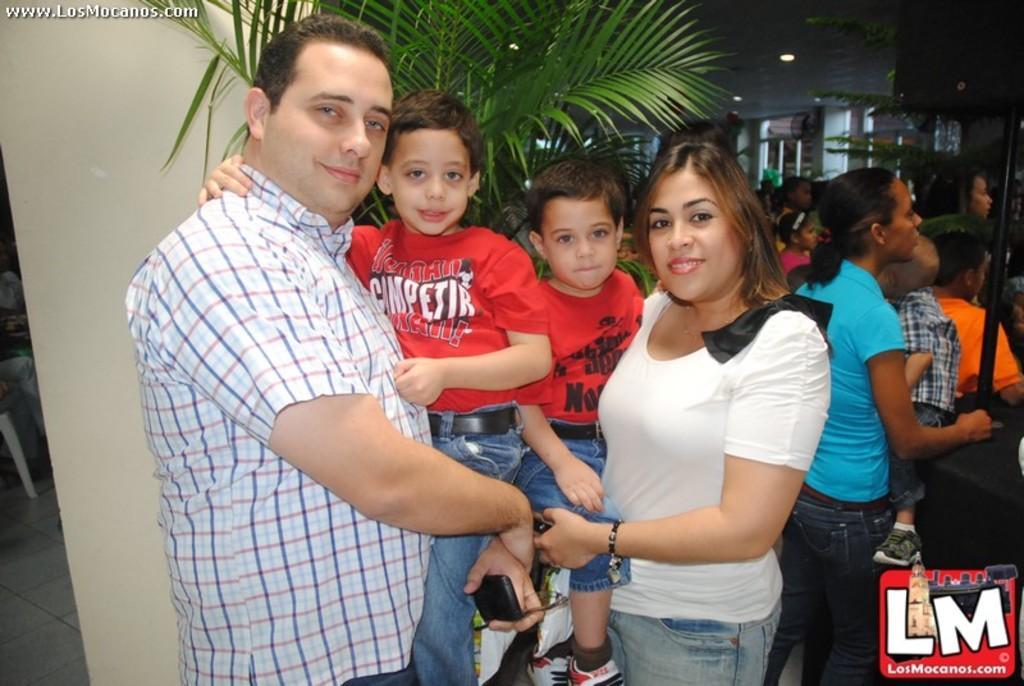Please provide a concise description of this image. The picture is taken from some website there are few people in the foreground and they are posing for the photo and behind them there are some other people and plants. 